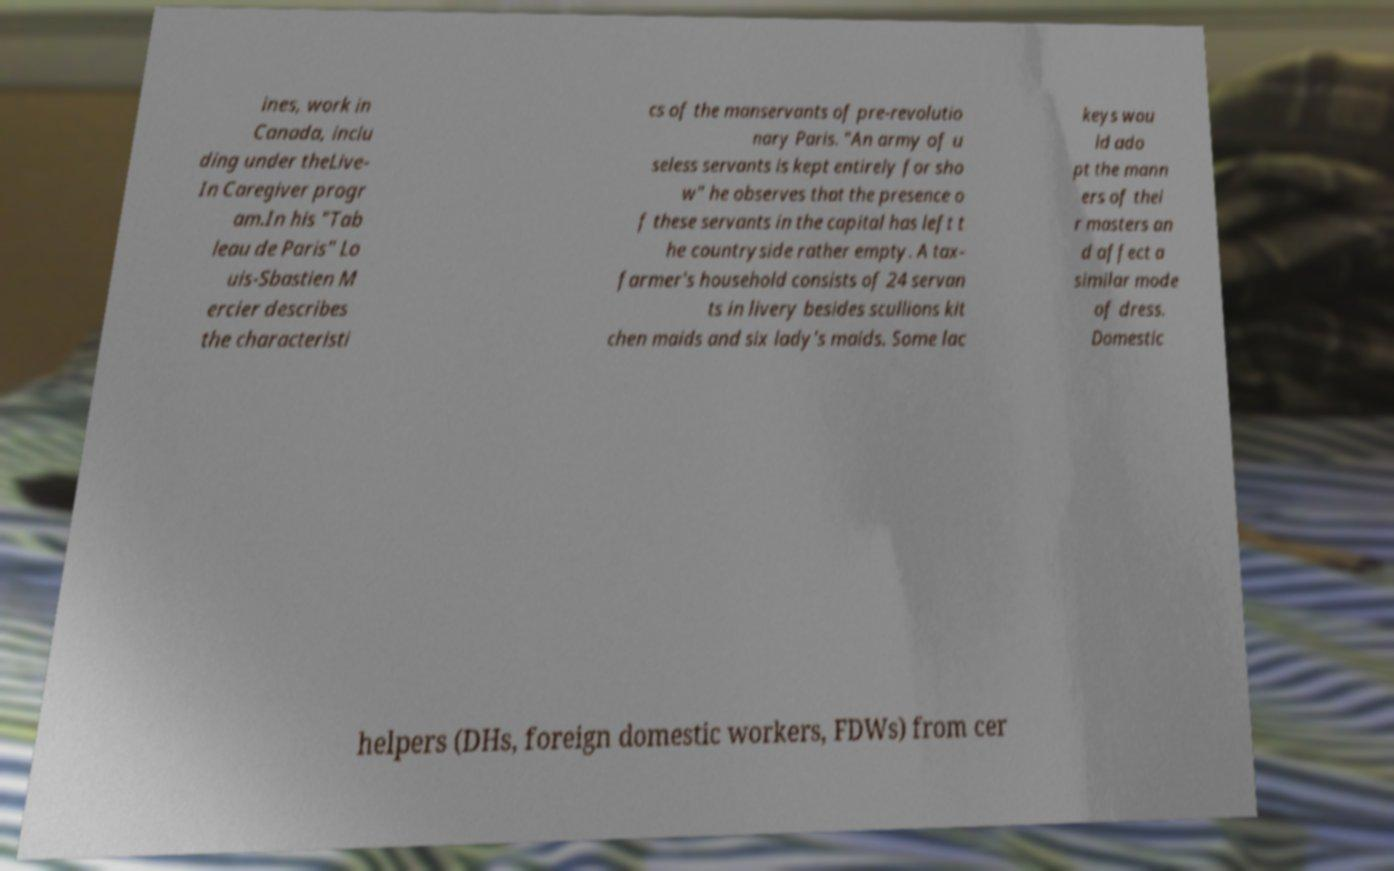For documentation purposes, I need the text within this image transcribed. Could you provide that? ines, work in Canada, inclu ding under theLive- In Caregiver progr am.In his "Tab leau de Paris" Lo uis-Sbastien M ercier describes the characteristi cs of the manservants of pre-revolutio nary Paris. "An army of u seless servants is kept entirely for sho w" he observes that the presence o f these servants in the capital has left t he countryside rather empty. A tax- farmer's household consists of 24 servan ts in livery besides scullions kit chen maids and six lady's maids. Some lac keys wou ld ado pt the mann ers of thei r masters an d affect a similar mode of dress. Domestic helpers (DHs, foreign domestic workers, FDWs) from cer 